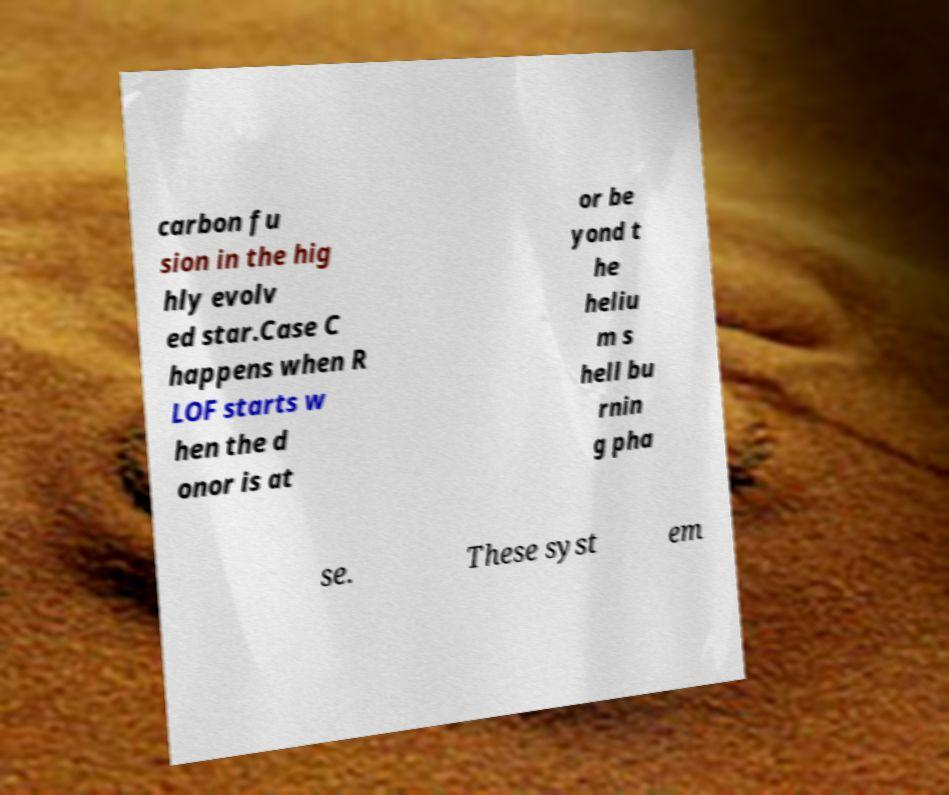There's text embedded in this image that I need extracted. Can you transcribe it verbatim? carbon fu sion in the hig hly evolv ed star.Case C happens when R LOF starts w hen the d onor is at or be yond t he heliu m s hell bu rnin g pha se. These syst em 